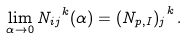Convert formula to latex. <formula><loc_0><loc_0><loc_500><loc_500>\lim _ { \alpha \rightarrow 0 } { N _ { i j } } ^ { k } ( \alpha ) = { ( N _ { p , I } ) _ { j } } ^ { k } \, .</formula> 